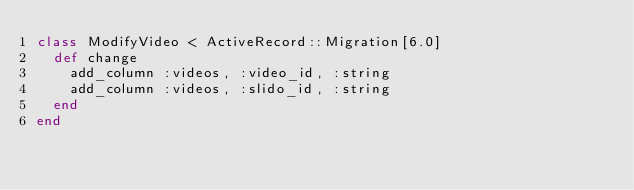Convert code to text. <code><loc_0><loc_0><loc_500><loc_500><_Ruby_>class ModifyVideo < ActiveRecord::Migration[6.0]
  def change
    add_column :videos, :video_id, :string
    add_column :videos, :slido_id, :string
  end
end
</code> 